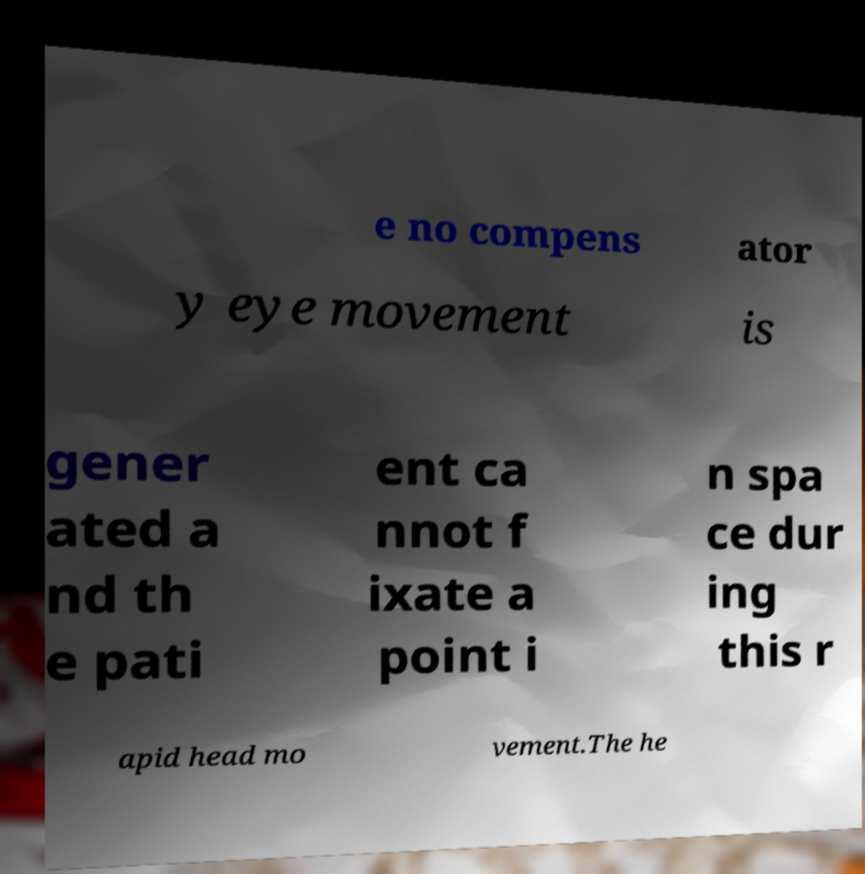Could you assist in decoding the text presented in this image and type it out clearly? e no compens ator y eye movement is gener ated a nd th e pati ent ca nnot f ixate a point i n spa ce dur ing this r apid head mo vement.The he 